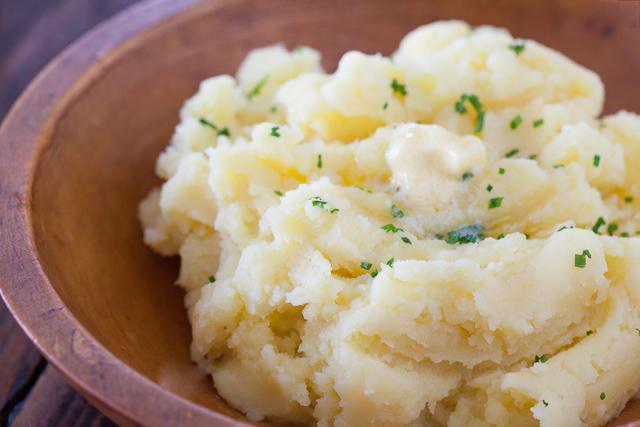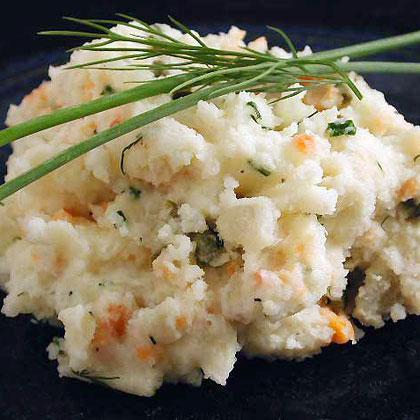The first image is the image on the left, the second image is the image on the right. Analyze the images presented: Is the assertion "Mashed potatoes in a black bowl with a ridge design are topped with melted butter and small pieces of chive." valid? Answer yes or no. No. The first image is the image on the left, the second image is the image on the right. Analyze the images presented: Is the assertion "There are green flakes garnishing only one of the dishes." valid? Answer yes or no. No. 